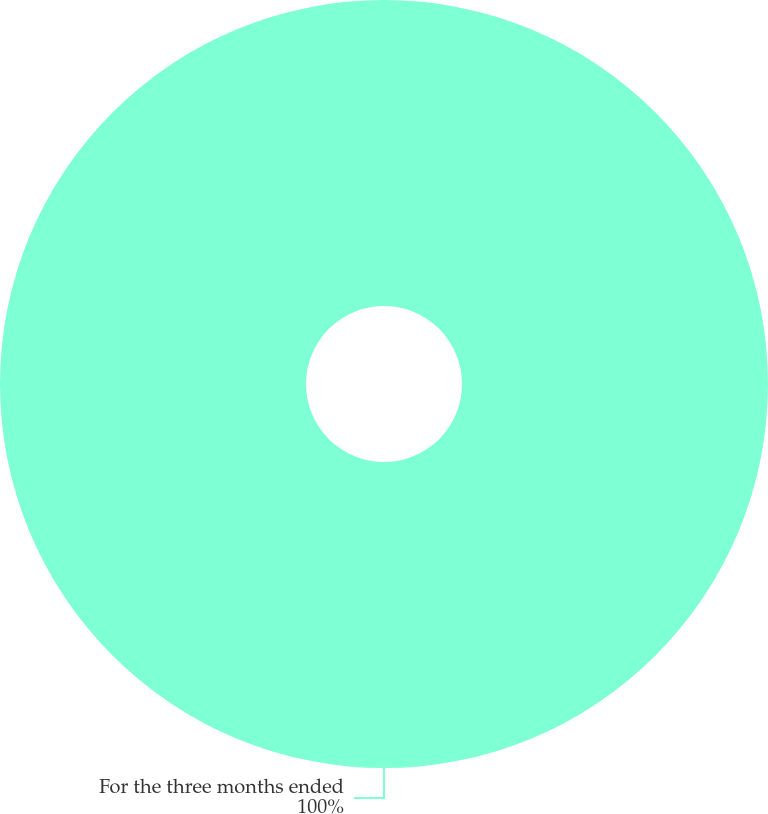Convert chart to OTSL. <chart><loc_0><loc_0><loc_500><loc_500><pie_chart><fcel>For the three months ended<nl><fcel>100.0%<nl></chart> 